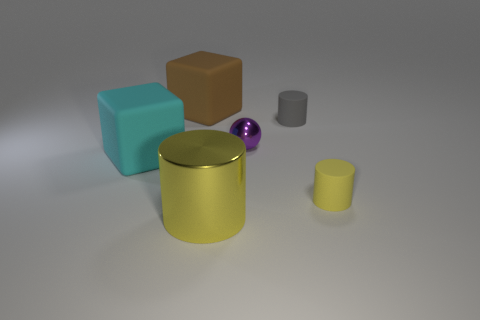Are there fewer cylinders on the left side of the small gray rubber cylinder than matte cylinders?
Provide a short and direct response. Yes. There is a small matte thing behind the tiny cylinder right of the rubber cylinder behind the metal sphere; what is its shape?
Your answer should be compact. Cylinder. Is the yellow matte object the same shape as the purple shiny object?
Keep it short and to the point. No. How many other things are there of the same shape as the big brown matte thing?
Ensure brevity in your answer.  1. What is the color of the other rubber object that is the same size as the gray thing?
Offer a terse response. Yellow. Are there the same number of tiny gray cylinders behind the tiny purple thing and purple balls?
Provide a short and direct response. Yes. What is the shape of the rubber thing that is on the right side of the big brown thing and behind the big cyan matte object?
Give a very brief answer. Cylinder. Do the yellow matte thing and the cyan rubber cube have the same size?
Make the answer very short. No. Is there a tiny object made of the same material as the tiny gray cylinder?
Offer a very short reply. Yes. What is the size of the cylinder that is the same color as the big metal thing?
Ensure brevity in your answer.  Small. 